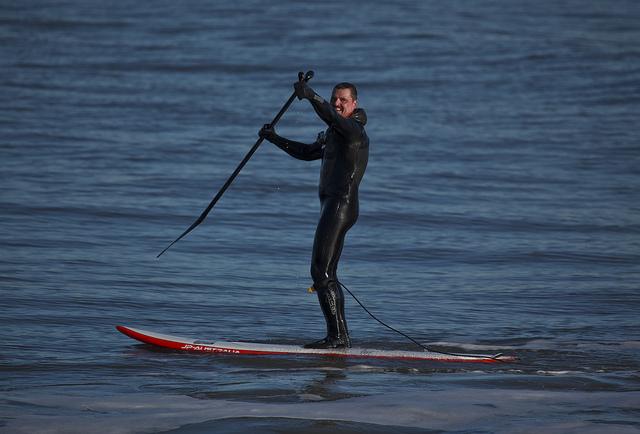What is the man holding?
Short answer required. Paddle. Are they on a sleigh?
Keep it brief. No. Is the man doing this for pleasure?
Give a very brief answer. Yes. How many people are in the photo?
Keep it brief. 1. What is the man standing on?
Concise answer only. Surfboard. 